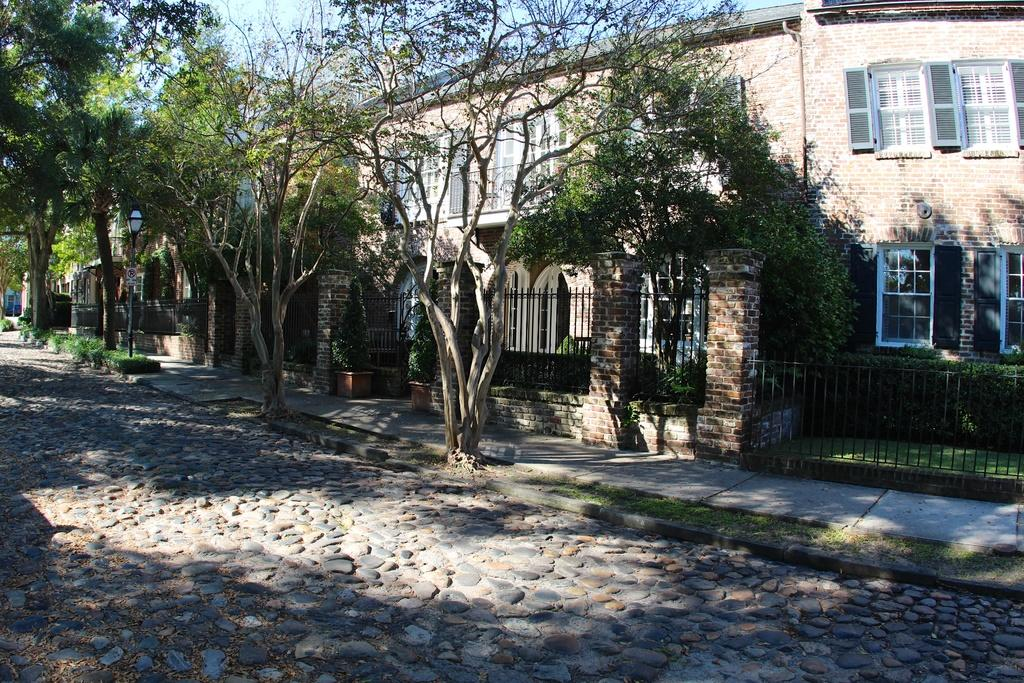What type of road is visible in the image? There is a pebble road in the image. What natural elements can be seen in the image? There are trees in the image. What man-made structure is present in the image? There is a fence in the image. What type of building can be seen in the image? There is a building in the image. What is visible at the top of the image? The sky is visible at the top of the image. Can you tell me how many partners are visible in the image? There are no partners present in the image. What type of cave can be seen in the image? There is no cave present in the image. 